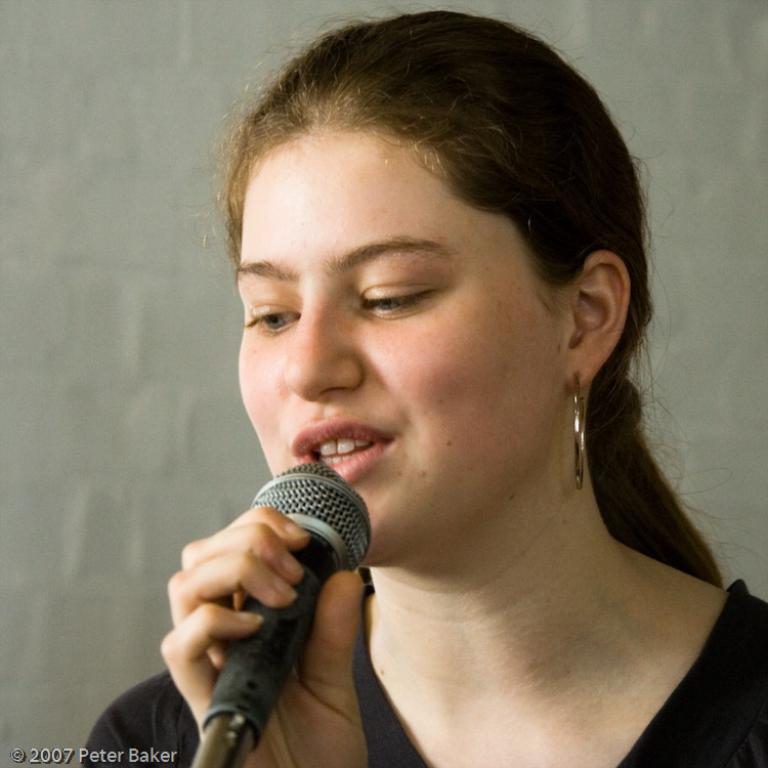How would you summarize this image in a sentence or two? In this image we have a woman who is wearing a black dress only phone and talking. 